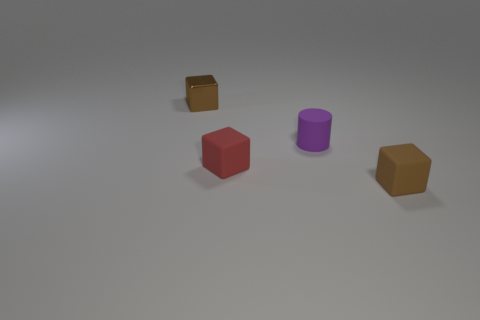Subtract all tiny brown cubes. How many cubes are left? 1 Add 3 tiny gray metallic cylinders. How many objects exist? 7 Subtract all red blocks. How many blocks are left? 2 Subtract all blocks. How many objects are left? 1 Subtract 1 cylinders. How many cylinders are left? 0 Subtract all yellow cubes. Subtract all green cylinders. How many cubes are left? 3 Subtract all green spheres. How many brown cubes are left? 2 Subtract all metallic cubes. Subtract all big green shiny spheres. How many objects are left? 3 Add 3 red objects. How many red objects are left? 4 Add 2 tiny metal cubes. How many tiny metal cubes exist? 3 